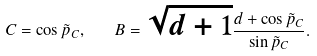<formula> <loc_0><loc_0><loc_500><loc_500>C = \cos \tilde { p } _ { C } , \quad B = \sqrt { d + 1 } \frac { d + \cos \tilde { p } _ { C } } { \sin \tilde { p } _ { C } } .</formula> 